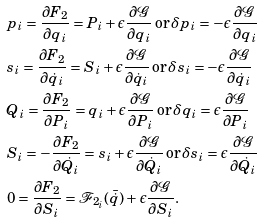Convert formula to latex. <formula><loc_0><loc_0><loc_500><loc_500>& p _ { i } = \frac { \partial F _ { 2 } } { \partial q _ { i } } = P _ { i } + \epsilon \frac { \partial \mathcal { G } } { \partial q _ { i } } \, \text {or} \, \delta p _ { i } = - \epsilon \frac { \partial \mathcal { G } } { \partial q _ { i } } \\ & s _ { i } = \frac { \partial F _ { 2 } } { \partial \dot { q } _ { i } } = S _ { i } + \epsilon \frac { \partial \mathcal { G } } { \partial \dot { q } _ { i } } \, \text {or} \, \delta s _ { i } = - \epsilon \frac { \partial \mathcal { G } } { \partial \dot { q } _ { i } } \\ & Q _ { i } = \frac { \partial F _ { 2 } } { \partial P _ { i } } = q _ { i } + \epsilon \frac { \partial \mathcal { G } } { \partial P _ { i } } \, \text {or} \, \delta q _ { i } = \epsilon \frac { \partial \mathcal { G } } { \partial P _ { i } } \\ & S _ { i } = - \frac { \partial F _ { 2 } } { \partial \dot { Q } _ { i } } = s _ { i } + \epsilon \frac { \partial \mathcal { G } } { \partial \dot { Q } _ { i } } \, \text {or} \, \delta s _ { i } = \epsilon \frac { \partial \mathcal { G } } { \partial \dot { Q } _ { i } } \\ & 0 = \frac { \partial F _ { 2 } } { \partial S _ { i } } = \mathcal { F } _ { 2 _ { i } } ( \bar { \dot { q } } ) + \epsilon \frac { \partial \mathcal { G } } { \partial S _ { i } } .</formula> 